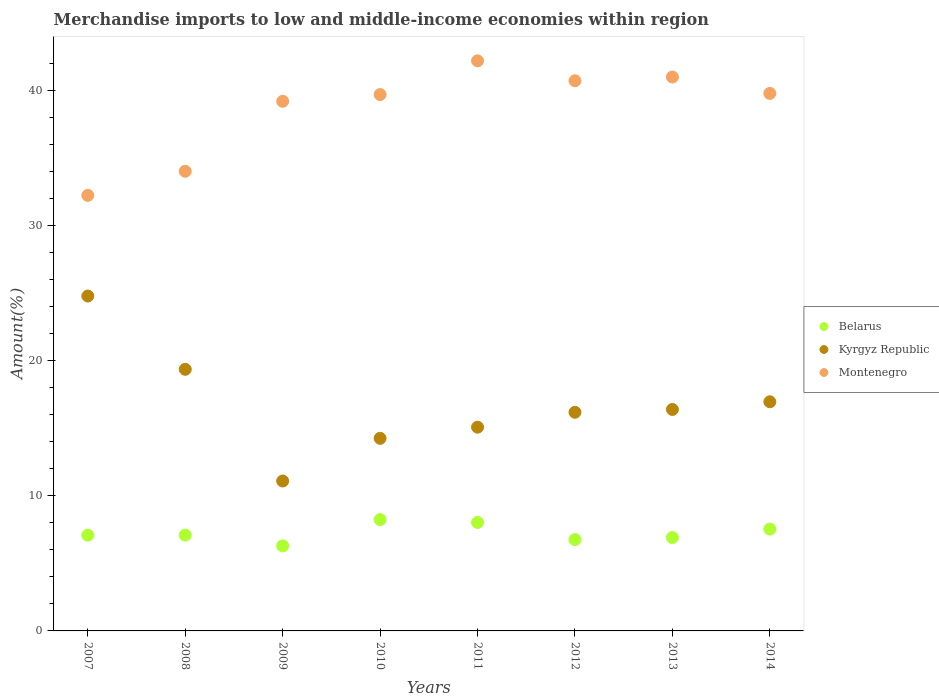How many different coloured dotlines are there?
Make the answer very short. 3. Is the number of dotlines equal to the number of legend labels?
Ensure brevity in your answer.  Yes. What is the percentage of amount earned from merchandise imports in Kyrgyz Republic in 2011?
Keep it short and to the point. 15.07. Across all years, what is the maximum percentage of amount earned from merchandise imports in Kyrgyz Republic?
Your answer should be compact. 24.77. Across all years, what is the minimum percentage of amount earned from merchandise imports in Belarus?
Keep it short and to the point. 6.29. In which year was the percentage of amount earned from merchandise imports in Kyrgyz Republic maximum?
Offer a terse response. 2007. In which year was the percentage of amount earned from merchandise imports in Kyrgyz Republic minimum?
Your answer should be compact. 2009. What is the total percentage of amount earned from merchandise imports in Belarus in the graph?
Keep it short and to the point. 57.93. What is the difference between the percentage of amount earned from merchandise imports in Belarus in 2012 and that in 2014?
Your answer should be compact. -0.77. What is the difference between the percentage of amount earned from merchandise imports in Montenegro in 2011 and the percentage of amount earned from merchandise imports in Belarus in 2007?
Make the answer very short. 35.09. What is the average percentage of amount earned from merchandise imports in Kyrgyz Republic per year?
Your answer should be very brief. 16.76. In the year 2008, what is the difference between the percentage of amount earned from merchandise imports in Kyrgyz Republic and percentage of amount earned from merchandise imports in Belarus?
Provide a short and direct response. 12.27. What is the ratio of the percentage of amount earned from merchandise imports in Belarus in 2010 to that in 2012?
Your answer should be compact. 1.22. Is the percentage of amount earned from merchandise imports in Belarus in 2009 less than that in 2012?
Provide a short and direct response. Yes. What is the difference between the highest and the second highest percentage of amount earned from merchandise imports in Kyrgyz Republic?
Keep it short and to the point. 5.42. What is the difference between the highest and the lowest percentage of amount earned from merchandise imports in Montenegro?
Provide a short and direct response. 9.95. Is it the case that in every year, the sum of the percentage of amount earned from merchandise imports in Kyrgyz Republic and percentage of amount earned from merchandise imports in Montenegro  is greater than the percentage of amount earned from merchandise imports in Belarus?
Offer a terse response. Yes. Does the graph contain grids?
Your answer should be very brief. No. How are the legend labels stacked?
Your response must be concise. Vertical. What is the title of the graph?
Your answer should be very brief. Merchandise imports to low and middle-income economies within region. What is the label or title of the Y-axis?
Your response must be concise. Amount(%). What is the Amount(%) in Belarus in 2007?
Your answer should be very brief. 7.08. What is the Amount(%) of Kyrgyz Republic in 2007?
Your answer should be very brief. 24.77. What is the Amount(%) of Montenegro in 2007?
Offer a very short reply. 32.22. What is the Amount(%) of Belarus in 2008?
Ensure brevity in your answer.  7.09. What is the Amount(%) of Kyrgyz Republic in 2008?
Offer a terse response. 19.35. What is the Amount(%) in Montenegro in 2008?
Your answer should be compact. 34. What is the Amount(%) in Belarus in 2009?
Your answer should be compact. 6.29. What is the Amount(%) in Kyrgyz Republic in 2009?
Your answer should be compact. 11.09. What is the Amount(%) of Montenegro in 2009?
Offer a terse response. 39.18. What is the Amount(%) in Belarus in 2010?
Your response must be concise. 8.24. What is the Amount(%) in Kyrgyz Republic in 2010?
Give a very brief answer. 14.25. What is the Amount(%) of Montenegro in 2010?
Give a very brief answer. 39.68. What is the Amount(%) in Belarus in 2011?
Keep it short and to the point. 8.03. What is the Amount(%) of Kyrgyz Republic in 2011?
Your answer should be very brief. 15.07. What is the Amount(%) of Montenegro in 2011?
Provide a succinct answer. 42.17. What is the Amount(%) of Belarus in 2012?
Your answer should be compact. 6.76. What is the Amount(%) of Kyrgyz Republic in 2012?
Offer a terse response. 16.17. What is the Amount(%) in Montenegro in 2012?
Your answer should be compact. 40.7. What is the Amount(%) of Belarus in 2013?
Your response must be concise. 6.91. What is the Amount(%) of Kyrgyz Republic in 2013?
Make the answer very short. 16.38. What is the Amount(%) of Montenegro in 2013?
Offer a terse response. 40.98. What is the Amount(%) of Belarus in 2014?
Provide a short and direct response. 7.53. What is the Amount(%) in Kyrgyz Republic in 2014?
Your answer should be very brief. 16.95. What is the Amount(%) in Montenegro in 2014?
Offer a very short reply. 39.76. Across all years, what is the maximum Amount(%) of Belarus?
Provide a short and direct response. 8.24. Across all years, what is the maximum Amount(%) in Kyrgyz Republic?
Offer a very short reply. 24.77. Across all years, what is the maximum Amount(%) of Montenegro?
Offer a terse response. 42.17. Across all years, what is the minimum Amount(%) of Belarus?
Give a very brief answer. 6.29. Across all years, what is the minimum Amount(%) of Kyrgyz Republic?
Offer a very short reply. 11.09. Across all years, what is the minimum Amount(%) of Montenegro?
Provide a short and direct response. 32.22. What is the total Amount(%) of Belarus in the graph?
Keep it short and to the point. 57.93. What is the total Amount(%) of Kyrgyz Republic in the graph?
Provide a succinct answer. 134.05. What is the total Amount(%) of Montenegro in the graph?
Provide a short and direct response. 308.69. What is the difference between the Amount(%) in Belarus in 2007 and that in 2008?
Offer a very short reply. -0. What is the difference between the Amount(%) in Kyrgyz Republic in 2007 and that in 2008?
Your answer should be compact. 5.42. What is the difference between the Amount(%) in Montenegro in 2007 and that in 2008?
Keep it short and to the point. -1.78. What is the difference between the Amount(%) of Belarus in 2007 and that in 2009?
Offer a terse response. 0.79. What is the difference between the Amount(%) in Kyrgyz Republic in 2007 and that in 2009?
Your answer should be very brief. 13.68. What is the difference between the Amount(%) of Montenegro in 2007 and that in 2009?
Offer a terse response. -6.96. What is the difference between the Amount(%) of Belarus in 2007 and that in 2010?
Ensure brevity in your answer.  -1.15. What is the difference between the Amount(%) of Kyrgyz Republic in 2007 and that in 2010?
Offer a terse response. 10.53. What is the difference between the Amount(%) in Montenegro in 2007 and that in 2010?
Your response must be concise. -7.46. What is the difference between the Amount(%) of Belarus in 2007 and that in 2011?
Your answer should be compact. -0.94. What is the difference between the Amount(%) in Kyrgyz Republic in 2007 and that in 2011?
Your answer should be compact. 9.7. What is the difference between the Amount(%) in Montenegro in 2007 and that in 2011?
Your answer should be compact. -9.95. What is the difference between the Amount(%) of Belarus in 2007 and that in 2012?
Ensure brevity in your answer.  0.32. What is the difference between the Amount(%) of Kyrgyz Republic in 2007 and that in 2012?
Your answer should be very brief. 8.6. What is the difference between the Amount(%) of Montenegro in 2007 and that in 2012?
Provide a short and direct response. -8.48. What is the difference between the Amount(%) in Belarus in 2007 and that in 2013?
Give a very brief answer. 0.17. What is the difference between the Amount(%) in Kyrgyz Republic in 2007 and that in 2013?
Your response must be concise. 8.39. What is the difference between the Amount(%) in Montenegro in 2007 and that in 2013?
Your answer should be compact. -8.76. What is the difference between the Amount(%) in Belarus in 2007 and that in 2014?
Provide a short and direct response. -0.45. What is the difference between the Amount(%) in Kyrgyz Republic in 2007 and that in 2014?
Your answer should be very brief. 7.82. What is the difference between the Amount(%) of Montenegro in 2007 and that in 2014?
Ensure brevity in your answer.  -7.54. What is the difference between the Amount(%) of Belarus in 2008 and that in 2009?
Give a very brief answer. 0.8. What is the difference between the Amount(%) of Kyrgyz Republic in 2008 and that in 2009?
Provide a succinct answer. 8.26. What is the difference between the Amount(%) in Montenegro in 2008 and that in 2009?
Provide a short and direct response. -5.18. What is the difference between the Amount(%) in Belarus in 2008 and that in 2010?
Give a very brief answer. -1.15. What is the difference between the Amount(%) in Kyrgyz Republic in 2008 and that in 2010?
Offer a terse response. 5.11. What is the difference between the Amount(%) of Montenegro in 2008 and that in 2010?
Provide a succinct answer. -5.68. What is the difference between the Amount(%) in Belarus in 2008 and that in 2011?
Ensure brevity in your answer.  -0.94. What is the difference between the Amount(%) of Kyrgyz Republic in 2008 and that in 2011?
Ensure brevity in your answer.  4.28. What is the difference between the Amount(%) of Montenegro in 2008 and that in 2011?
Ensure brevity in your answer.  -8.17. What is the difference between the Amount(%) in Belarus in 2008 and that in 2012?
Give a very brief answer. 0.33. What is the difference between the Amount(%) in Kyrgyz Republic in 2008 and that in 2012?
Provide a succinct answer. 3.18. What is the difference between the Amount(%) of Montenegro in 2008 and that in 2012?
Provide a succinct answer. -6.7. What is the difference between the Amount(%) in Belarus in 2008 and that in 2013?
Offer a very short reply. 0.18. What is the difference between the Amount(%) of Kyrgyz Republic in 2008 and that in 2013?
Make the answer very short. 2.97. What is the difference between the Amount(%) in Montenegro in 2008 and that in 2013?
Give a very brief answer. -6.97. What is the difference between the Amount(%) of Belarus in 2008 and that in 2014?
Offer a very short reply. -0.45. What is the difference between the Amount(%) in Kyrgyz Republic in 2008 and that in 2014?
Make the answer very short. 2.4. What is the difference between the Amount(%) in Montenegro in 2008 and that in 2014?
Offer a very short reply. -5.76. What is the difference between the Amount(%) in Belarus in 2009 and that in 2010?
Provide a short and direct response. -1.95. What is the difference between the Amount(%) in Kyrgyz Republic in 2009 and that in 2010?
Ensure brevity in your answer.  -3.16. What is the difference between the Amount(%) in Montenegro in 2009 and that in 2010?
Make the answer very short. -0.5. What is the difference between the Amount(%) in Belarus in 2009 and that in 2011?
Give a very brief answer. -1.74. What is the difference between the Amount(%) in Kyrgyz Republic in 2009 and that in 2011?
Your answer should be compact. -3.98. What is the difference between the Amount(%) of Montenegro in 2009 and that in 2011?
Your response must be concise. -2.99. What is the difference between the Amount(%) in Belarus in 2009 and that in 2012?
Your answer should be compact. -0.47. What is the difference between the Amount(%) in Kyrgyz Republic in 2009 and that in 2012?
Your answer should be compact. -5.08. What is the difference between the Amount(%) of Montenegro in 2009 and that in 2012?
Offer a very short reply. -1.52. What is the difference between the Amount(%) of Belarus in 2009 and that in 2013?
Your answer should be very brief. -0.62. What is the difference between the Amount(%) of Kyrgyz Republic in 2009 and that in 2013?
Give a very brief answer. -5.29. What is the difference between the Amount(%) of Montenegro in 2009 and that in 2013?
Keep it short and to the point. -1.8. What is the difference between the Amount(%) of Belarus in 2009 and that in 2014?
Offer a very short reply. -1.24. What is the difference between the Amount(%) of Kyrgyz Republic in 2009 and that in 2014?
Make the answer very short. -5.86. What is the difference between the Amount(%) in Montenegro in 2009 and that in 2014?
Your answer should be very brief. -0.58. What is the difference between the Amount(%) of Belarus in 2010 and that in 2011?
Ensure brevity in your answer.  0.21. What is the difference between the Amount(%) in Kyrgyz Republic in 2010 and that in 2011?
Provide a short and direct response. -0.82. What is the difference between the Amount(%) in Montenegro in 2010 and that in 2011?
Make the answer very short. -2.49. What is the difference between the Amount(%) in Belarus in 2010 and that in 2012?
Your answer should be compact. 1.48. What is the difference between the Amount(%) of Kyrgyz Republic in 2010 and that in 2012?
Give a very brief answer. -1.93. What is the difference between the Amount(%) of Montenegro in 2010 and that in 2012?
Ensure brevity in your answer.  -1.02. What is the difference between the Amount(%) of Belarus in 2010 and that in 2013?
Offer a terse response. 1.33. What is the difference between the Amount(%) of Kyrgyz Republic in 2010 and that in 2013?
Make the answer very short. -2.13. What is the difference between the Amount(%) of Montenegro in 2010 and that in 2013?
Make the answer very short. -1.3. What is the difference between the Amount(%) of Belarus in 2010 and that in 2014?
Offer a very short reply. 0.7. What is the difference between the Amount(%) in Kyrgyz Republic in 2010 and that in 2014?
Make the answer very short. -2.7. What is the difference between the Amount(%) in Montenegro in 2010 and that in 2014?
Provide a short and direct response. -0.08. What is the difference between the Amount(%) in Belarus in 2011 and that in 2012?
Make the answer very short. 1.27. What is the difference between the Amount(%) in Kyrgyz Republic in 2011 and that in 2012?
Offer a very short reply. -1.1. What is the difference between the Amount(%) in Montenegro in 2011 and that in 2012?
Keep it short and to the point. 1.47. What is the difference between the Amount(%) in Belarus in 2011 and that in 2013?
Keep it short and to the point. 1.12. What is the difference between the Amount(%) of Kyrgyz Republic in 2011 and that in 2013?
Give a very brief answer. -1.31. What is the difference between the Amount(%) in Montenegro in 2011 and that in 2013?
Offer a terse response. 1.2. What is the difference between the Amount(%) of Belarus in 2011 and that in 2014?
Keep it short and to the point. 0.49. What is the difference between the Amount(%) in Kyrgyz Republic in 2011 and that in 2014?
Provide a short and direct response. -1.88. What is the difference between the Amount(%) of Montenegro in 2011 and that in 2014?
Your response must be concise. 2.41. What is the difference between the Amount(%) of Belarus in 2012 and that in 2013?
Your answer should be very brief. -0.15. What is the difference between the Amount(%) of Kyrgyz Republic in 2012 and that in 2013?
Offer a very short reply. -0.21. What is the difference between the Amount(%) in Montenegro in 2012 and that in 2013?
Keep it short and to the point. -0.28. What is the difference between the Amount(%) of Belarus in 2012 and that in 2014?
Offer a very short reply. -0.77. What is the difference between the Amount(%) of Kyrgyz Republic in 2012 and that in 2014?
Offer a terse response. -0.78. What is the difference between the Amount(%) of Montenegro in 2012 and that in 2014?
Provide a short and direct response. 0.94. What is the difference between the Amount(%) of Belarus in 2013 and that in 2014?
Your response must be concise. -0.62. What is the difference between the Amount(%) in Kyrgyz Republic in 2013 and that in 2014?
Your answer should be very brief. -0.57. What is the difference between the Amount(%) of Montenegro in 2013 and that in 2014?
Provide a short and direct response. 1.21. What is the difference between the Amount(%) in Belarus in 2007 and the Amount(%) in Kyrgyz Republic in 2008?
Ensure brevity in your answer.  -12.27. What is the difference between the Amount(%) of Belarus in 2007 and the Amount(%) of Montenegro in 2008?
Ensure brevity in your answer.  -26.92. What is the difference between the Amount(%) of Kyrgyz Republic in 2007 and the Amount(%) of Montenegro in 2008?
Your answer should be very brief. -9.23. What is the difference between the Amount(%) in Belarus in 2007 and the Amount(%) in Kyrgyz Republic in 2009?
Keep it short and to the point. -4.01. What is the difference between the Amount(%) in Belarus in 2007 and the Amount(%) in Montenegro in 2009?
Your answer should be very brief. -32.09. What is the difference between the Amount(%) of Kyrgyz Republic in 2007 and the Amount(%) of Montenegro in 2009?
Ensure brevity in your answer.  -14.41. What is the difference between the Amount(%) of Belarus in 2007 and the Amount(%) of Kyrgyz Republic in 2010?
Offer a very short reply. -7.16. What is the difference between the Amount(%) in Belarus in 2007 and the Amount(%) in Montenegro in 2010?
Offer a very short reply. -32.59. What is the difference between the Amount(%) in Kyrgyz Republic in 2007 and the Amount(%) in Montenegro in 2010?
Give a very brief answer. -14.9. What is the difference between the Amount(%) of Belarus in 2007 and the Amount(%) of Kyrgyz Republic in 2011?
Ensure brevity in your answer.  -7.99. What is the difference between the Amount(%) of Belarus in 2007 and the Amount(%) of Montenegro in 2011?
Keep it short and to the point. -35.09. What is the difference between the Amount(%) of Kyrgyz Republic in 2007 and the Amount(%) of Montenegro in 2011?
Your answer should be compact. -17.4. What is the difference between the Amount(%) of Belarus in 2007 and the Amount(%) of Kyrgyz Republic in 2012?
Offer a terse response. -9.09. What is the difference between the Amount(%) of Belarus in 2007 and the Amount(%) of Montenegro in 2012?
Offer a terse response. -33.61. What is the difference between the Amount(%) of Kyrgyz Republic in 2007 and the Amount(%) of Montenegro in 2012?
Keep it short and to the point. -15.93. What is the difference between the Amount(%) in Belarus in 2007 and the Amount(%) in Kyrgyz Republic in 2013?
Offer a very short reply. -9.3. What is the difference between the Amount(%) of Belarus in 2007 and the Amount(%) of Montenegro in 2013?
Provide a short and direct response. -33.89. What is the difference between the Amount(%) of Kyrgyz Republic in 2007 and the Amount(%) of Montenegro in 2013?
Make the answer very short. -16.2. What is the difference between the Amount(%) of Belarus in 2007 and the Amount(%) of Kyrgyz Republic in 2014?
Keep it short and to the point. -9.87. What is the difference between the Amount(%) in Belarus in 2007 and the Amount(%) in Montenegro in 2014?
Offer a very short reply. -32.68. What is the difference between the Amount(%) of Kyrgyz Republic in 2007 and the Amount(%) of Montenegro in 2014?
Give a very brief answer. -14.99. What is the difference between the Amount(%) in Belarus in 2008 and the Amount(%) in Kyrgyz Republic in 2009?
Offer a terse response. -4. What is the difference between the Amount(%) of Belarus in 2008 and the Amount(%) of Montenegro in 2009?
Offer a terse response. -32.09. What is the difference between the Amount(%) of Kyrgyz Republic in 2008 and the Amount(%) of Montenegro in 2009?
Offer a very short reply. -19.83. What is the difference between the Amount(%) in Belarus in 2008 and the Amount(%) in Kyrgyz Republic in 2010?
Your response must be concise. -7.16. What is the difference between the Amount(%) of Belarus in 2008 and the Amount(%) of Montenegro in 2010?
Offer a terse response. -32.59. What is the difference between the Amount(%) in Kyrgyz Republic in 2008 and the Amount(%) in Montenegro in 2010?
Provide a succinct answer. -20.32. What is the difference between the Amount(%) of Belarus in 2008 and the Amount(%) of Kyrgyz Republic in 2011?
Your response must be concise. -7.99. What is the difference between the Amount(%) of Belarus in 2008 and the Amount(%) of Montenegro in 2011?
Your answer should be compact. -35.09. What is the difference between the Amount(%) of Kyrgyz Republic in 2008 and the Amount(%) of Montenegro in 2011?
Make the answer very short. -22.82. What is the difference between the Amount(%) in Belarus in 2008 and the Amount(%) in Kyrgyz Republic in 2012?
Ensure brevity in your answer.  -9.09. What is the difference between the Amount(%) of Belarus in 2008 and the Amount(%) of Montenegro in 2012?
Your response must be concise. -33.61. What is the difference between the Amount(%) of Kyrgyz Republic in 2008 and the Amount(%) of Montenegro in 2012?
Your answer should be very brief. -21.35. What is the difference between the Amount(%) of Belarus in 2008 and the Amount(%) of Kyrgyz Republic in 2013?
Your response must be concise. -9.3. What is the difference between the Amount(%) of Belarus in 2008 and the Amount(%) of Montenegro in 2013?
Give a very brief answer. -33.89. What is the difference between the Amount(%) in Kyrgyz Republic in 2008 and the Amount(%) in Montenegro in 2013?
Provide a short and direct response. -21.62. What is the difference between the Amount(%) in Belarus in 2008 and the Amount(%) in Kyrgyz Republic in 2014?
Provide a short and direct response. -9.87. What is the difference between the Amount(%) in Belarus in 2008 and the Amount(%) in Montenegro in 2014?
Your answer should be very brief. -32.68. What is the difference between the Amount(%) of Kyrgyz Republic in 2008 and the Amount(%) of Montenegro in 2014?
Provide a succinct answer. -20.41. What is the difference between the Amount(%) of Belarus in 2009 and the Amount(%) of Kyrgyz Republic in 2010?
Offer a very short reply. -7.96. What is the difference between the Amount(%) of Belarus in 2009 and the Amount(%) of Montenegro in 2010?
Your answer should be compact. -33.39. What is the difference between the Amount(%) of Kyrgyz Republic in 2009 and the Amount(%) of Montenegro in 2010?
Give a very brief answer. -28.59. What is the difference between the Amount(%) in Belarus in 2009 and the Amount(%) in Kyrgyz Republic in 2011?
Your answer should be compact. -8.78. What is the difference between the Amount(%) in Belarus in 2009 and the Amount(%) in Montenegro in 2011?
Your response must be concise. -35.88. What is the difference between the Amount(%) of Kyrgyz Republic in 2009 and the Amount(%) of Montenegro in 2011?
Your response must be concise. -31.08. What is the difference between the Amount(%) of Belarus in 2009 and the Amount(%) of Kyrgyz Republic in 2012?
Keep it short and to the point. -9.88. What is the difference between the Amount(%) of Belarus in 2009 and the Amount(%) of Montenegro in 2012?
Offer a terse response. -34.41. What is the difference between the Amount(%) of Kyrgyz Republic in 2009 and the Amount(%) of Montenegro in 2012?
Provide a short and direct response. -29.61. What is the difference between the Amount(%) of Belarus in 2009 and the Amount(%) of Kyrgyz Republic in 2013?
Provide a short and direct response. -10.09. What is the difference between the Amount(%) of Belarus in 2009 and the Amount(%) of Montenegro in 2013?
Give a very brief answer. -34.69. What is the difference between the Amount(%) in Kyrgyz Republic in 2009 and the Amount(%) in Montenegro in 2013?
Your answer should be compact. -29.89. What is the difference between the Amount(%) of Belarus in 2009 and the Amount(%) of Kyrgyz Republic in 2014?
Your answer should be very brief. -10.66. What is the difference between the Amount(%) of Belarus in 2009 and the Amount(%) of Montenegro in 2014?
Your answer should be very brief. -33.47. What is the difference between the Amount(%) in Kyrgyz Republic in 2009 and the Amount(%) in Montenegro in 2014?
Give a very brief answer. -28.67. What is the difference between the Amount(%) in Belarus in 2010 and the Amount(%) in Kyrgyz Republic in 2011?
Offer a terse response. -6.83. What is the difference between the Amount(%) in Belarus in 2010 and the Amount(%) in Montenegro in 2011?
Give a very brief answer. -33.94. What is the difference between the Amount(%) in Kyrgyz Republic in 2010 and the Amount(%) in Montenegro in 2011?
Give a very brief answer. -27.93. What is the difference between the Amount(%) in Belarus in 2010 and the Amount(%) in Kyrgyz Republic in 2012?
Make the answer very short. -7.94. What is the difference between the Amount(%) of Belarus in 2010 and the Amount(%) of Montenegro in 2012?
Your response must be concise. -32.46. What is the difference between the Amount(%) of Kyrgyz Republic in 2010 and the Amount(%) of Montenegro in 2012?
Your response must be concise. -26.45. What is the difference between the Amount(%) in Belarus in 2010 and the Amount(%) in Kyrgyz Republic in 2013?
Make the answer very short. -8.15. What is the difference between the Amount(%) in Belarus in 2010 and the Amount(%) in Montenegro in 2013?
Give a very brief answer. -32.74. What is the difference between the Amount(%) of Kyrgyz Republic in 2010 and the Amount(%) of Montenegro in 2013?
Provide a short and direct response. -26.73. What is the difference between the Amount(%) in Belarus in 2010 and the Amount(%) in Kyrgyz Republic in 2014?
Your answer should be compact. -8.71. What is the difference between the Amount(%) of Belarus in 2010 and the Amount(%) of Montenegro in 2014?
Your response must be concise. -31.52. What is the difference between the Amount(%) in Kyrgyz Republic in 2010 and the Amount(%) in Montenegro in 2014?
Provide a succinct answer. -25.51. What is the difference between the Amount(%) of Belarus in 2011 and the Amount(%) of Kyrgyz Republic in 2012?
Your answer should be very brief. -8.15. What is the difference between the Amount(%) of Belarus in 2011 and the Amount(%) of Montenegro in 2012?
Give a very brief answer. -32.67. What is the difference between the Amount(%) of Kyrgyz Republic in 2011 and the Amount(%) of Montenegro in 2012?
Your answer should be very brief. -25.63. What is the difference between the Amount(%) of Belarus in 2011 and the Amount(%) of Kyrgyz Republic in 2013?
Your response must be concise. -8.35. What is the difference between the Amount(%) in Belarus in 2011 and the Amount(%) in Montenegro in 2013?
Give a very brief answer. -32.95. What is the difference between the Amount(%) in Kyrgyz Republic in 2011 and the Amount(%) in Montenegro in 2013?
Provide a short and direct response. -25.9. What is the difference between the Amount(%) of Belarus in 2011 and the Amount(%) of Kyrgyz Republic in 2014?
Provide a succinct answer. -8.92. What is the difference between the Amount(%) in Belarus in 2011 and the Amount(%) in Montenegro in 2014?
Keep it short and to the point. -31.73. What is the difference between the Amount(%) in Kyrgyz Republic in 2011 and the Amount(%) in Montenegro in 2014?
Make the answer very short. -24.69. What is the difference between the Amount(%) of Belarus in 2012 and the Amount(%) of Kyrgyz Republic in 2013?
Provide a short and direct response. -9.62. What is the difference between the Amount(%) in Belarus in 2012 and the Amount(%) in Montenegro in 2013?
Ensure brevity in your answer.  -34.22. What is the difference between the Amount(%) of Kyrgyz Republic in 2012 and the Amount(%) of Montenegro in 2013?
Provide a short and direct response. -24.8. What is the difference between the Amount(%) in Belarus in 2012 and the Amount(%) in Kyrgyz Republic in 2014?
Keep it short and to the point. -10.19. What is the difference between the Amount(%) of Belarus in 2012 and the Amount(%) of Montenegro in 2014?
Your answer should be very brief. -33. What is the difference between the Amount(%) in Kyrgyz Republic in 2012 and the Amount(%) in Montenegro in 2014?
Provide a succinct answer. -23.59. What is the difference between the Amount(%) in Belarus in 2013 and the Amount(%) in Kyrgyz Republic in 2014?
Your answer should be compact. -10.04. What is the difference between the Amount(%) in Belarus in 2013 and the Amount(%) in Montenegro in 2014?
Keep it short and to the point. -32.85. What is the difference between the Amount(%) in Kyrgyz Republic in 2013 and the Amount(%) in Montenegro in 2014?
Provide a succinct answer. -23.38. What is the average Amount(%) in Belarus per year?
Ensure brevity in your answer.  7.24. What is the average Amount(%) in Kyrgyz Republic per year?
Make the answer very short. 16.76. What is the average Amount(%) of Montenegro per year?
Offer a terse response. 38.59. In the year 2007, what is the difference between the Amount(%) of Belarus and Amount(%) of Kyrgyz Republic?
Provide a short and direct response. -17.69. In the year 2007, what is the difference between the Amount(%) of Belarus and Amount(%) of Montenegro?
Make the answer very short. -25.14. In the year 2007, what is the difference between the Amount(%) in Kyrgyz Republic and Amount(%) in Montenegro?
Keep it short and to the point. -7.45. In the year 2008, what is the difference between the Amount(%) of Belarus and Amount(%) of Kyrgyz Republic?
Provide a succinct answer. -12.27. In the year 2008, what is the difference between the Amount(%) in Belarus and Amount(%) in Montenegro?
Provide a short and direct response. -26.91. In the year 2008, what is the difference between the Amount(%) in Kyrgyz Republic and Amount(%) in Montenegro?
Provide a short and direct response. -14.65. In the year 2009, what is the difference between the Amount(%) in Belarus and Amount(%) in Kyrgyz Republic?
Give a very brief answer. -4.8. In the year 2009, what is the difference between the Amount(%) in Belarus and Amount(%) in Montenegro?
Provide a succinct answer. -32.89. In the year 2009, what is the difference between the Amount(%) of Kyrgyz Republic and Amount(%) of Montenegro?
Your response must be concise. -28.09. In the year 2010, what is the difference between the Amount(%) in Belarus and Amount(%) in Kyrgyz Republic?
Your answer should be very brief. -6.01. In the year 2010, what is the difference between the Amount(%) in Belarus and Amount(%) in Montenegro?
Your response must be concise. -31.44. In the year 2010, what is the difference between the Amount(%) in Kyrgyz Republic and Amount(%) in Montenegro?
Keep it short and to the point. -25.43. In the year 2011, what is the difference between the Amount(%) of Belarus and Amount(%) of Kyrgyz Republic?
Your response must be concise. -7.04. In the year 2011, what is the difference between the Amount(%) in Belarus and Amount(%) in Montenegro?
Keep it short and to the point. -34.14. In the year 2011, what is the difference between the Amount(%) of Kyrgyz Republic and Amount(%) of Montenegro?
Keep it short and to the point. -27.1. In the year 2012, what is the difference between the Amount(%) in Belarus and Amount(%) in Kyrgyz Republic?
Make the answer very short. -9.42. In the year 2012, what is the difference between the Amount(%) in Belarus and Amount(%) in Montenegro?
Your answer should be compact. -33.94. In the year 2012, what is the difference between the Amount(%) in Kyrgyz Republic and Amount(%) in Montenegro?
Provide a succinct answer. -24.52. In the year 2013, what is the difference between the Amount(%) in Belarus and Amount(%) in Kyrgyz Republic?
Your answer should be compact. -9.47. In the year 2013, what is the difference between the Amount(%) of Belarus and Amount(%) of Montenegro?
Keep it short and to the point. -34.07. In the year 2013, what is the difference between the Amount(%) in Kyrgyz Republic and Amount(%) in Montenegro?
Ensure brevity in your answer.  -24.59. In the year 2014, what is the difference between the Amount(%) in Belarus and Amount(%) in Kyrgyz Republic?
Offer a terse response. -9.42. In the year 2014, what is the difference between the Amount(%) in Belarus and Amount(%) in Montenegro?
Keep it short and to the point. -32.23. In the year 2014, what is the difference between the Amount(%) in Kyrgyz Republic and Amount(%) in Montenegro?
Provide a short and direct response. -22.81. What is the ratio of the Amount(%) of Belarus in 2007 to that in 2008?
Offer a terse response. 1. What is the ratio of the Amount(%) in Kyrgyz Republic in 2007 to that in 2008?
Your answer should be compact. 1.28. What is the ratio of the Amount(%) of Montenegro in 2007 to that in 2008?
Give a very brief answer. 0.95. What is the ratio of the Amount(%) in Belarus in 2007 to that in 2009?
Offer a very short reply. 1.13. What is the ratio of the Amount(%) of Kyrgyz Republic in 2007 to that in 2009?
Provide a succinct answer. 2.23. What is the ratio of the Amount(%) of Montenegro in 2007 to that in 2009?
Make the answer very short. 0.82. What is the ratio of the Amount(%) of Belarus in 2007 to that in 2010?
Offer a terse response. 0.86. What is the ratio of the Amount(%) of Kyrgyz Republic in 2007 to that in 2010?
Make the answer very short. 1.74. What is the ratio of the Amount(%) of Montenegro in 2007 to that in 2010?
Offer a terse response. 0.81. What is the ratio of the Amount(%) in Belarus in 2007 to that in 2011?
Your answer should be very brief. 0.88. What is the ratio of the Amount(%) in Kyrgyz Republic in 2007 to that in 2011?
Make the answer very short. 1.64. What is the ratio of the Amount(%) in Montenegro in 2007 to that in 2011?
Give a very brief answer. 0.76. What is the ratio of the Amount(%) of Belarus in 2007 to that in 2012?
Provide a short and direct response. 1.05. What is the ratio of the Amount(%) of Kyrgyz Republic in 2007 to that in 2012?
Make the answer very short. 1.53. What is the ratio of the Amount(%) of Montenegro in 2007 to that in 2012?
Ensure brevity in your answer.  0.79. What is the ratio of the Amount(%) in Belarus in 2007 to that in 2013?
Give a very brief answer. 1.03. What is the ratio of the Amount(%) of Kyrgyz Republic in 2007 to that in 2013?
Offer a very short reply. 1.51. What is the ratio of the Amount(%) in Montenegro in 2007 to that in 2013?
Offer a very short reply. 0.79. What is the ratio of the Amount(%) of Belarus in 2007 to that in 2014?
Make the answer very short. 0.94. What is the ratio of the Amount(%) in Kyrgyz Republic in 2007 to that in 2014?
Your response must be concise. 1.46. What is the ratio of the Amount(%) of Montenegro in 2007 to that in 2014?
Your answer should be compact. 0.81. What is the ratio of the Amount(%) of Belarus in 2008 to that in 2009?
Give a very brief answer. 1.13. What is the ratio of the Amount(%) of Kyrgyz Republic in 2008 to that in 2009?
Make the answer very short. 1.75. What is the ratio of the Amount(%) of Montenegro in 2008 to that in 2009?
Give a very brief answer. 0.87. What is the ratio of the Amount(%) of Belarus in 2008 to that in 2010?
Offer a terse response. 0.86. What is the ratio of the Amount(%) in Kyrgyz Republic in 2008 to that in 2010?
Offer a terse response. 1.36. What is the ratio of the Amount(%) of Montenegro in 2008 to that in 2010?
Your response must be concise. 0.86. What is the ratio of the Amount(%) of Belarus in 2008 to that in 2011?
Your response must be concise. 0.88. What is the ratio of the Amount(%) of Kyrgyz Republic in 2008 to that in 2011?
Offer a very short reply. 1.28. What is the ratio of the Amount(%) of Montenegro in 2008 to that in 2011?
Offer a very short reply. 0.81. What is the ratio of the Amount(%) in Belarus in 2008 to that in 2012?
Make the answer very short. 1.05. What is the ratio of the Amount(%) of Kyrgyz Republic in 2008 to that in 2012?
Provide a succinct answer. 1.2. What is the ratio of the Amount(%) in Montenegro in 2008 to that in 2012?
Ensure brevity in your answer.  0.84. What is the ratio of the Amount(%) in Belarus in 2008 to that in 2013?
Provide a succinct answer. 1.03. What is the ratio of the Amount(%) in Kyrgyz Republic in 2008 to that in 2013?
Offer a very short reply. 1.18. What is the ratio of the Amount(%) in Montenegro in 2008 to that in 2013?
Offer a terse response. 0.83. What is the ratio of the Amount(%) of Belarus in 2008 to that in 2014?
Keep it short and to the point. 0.94. What is the ratio of the Amount(%) of Kyrgyz Republic in 2008 to that in 2014?
Keep it short and to the point. 1.14. What is the ratio of the Amount(%) of Montenegro in 2008 to that in 2014?
Ensure brevity in your answer.  0.86. What is the ratio of the Amount(%) of Belarus in 2009 to that in 2010?
Give a very brief answer. 0.76. What is the ratio of the Amount(%) of Kyrgyz Republic in 2009 to that in 2010?
Offer a terse response. 0.78. What is the ratio of the Amount(%) of Montenegro in 2009 to that in 2010?
Provide a succinct answer. 0.99. What is the ratio of the Amount(%) in Belarus in 2009 to that in 2011?
Your answer should be very brief. 0.78. What is the ratio of the Amount(%) of Kyrgyz Republic in 2009 to that in 2011?
Offer a very short reply. 0.74. What is the ratio of the Amount(%) of Montenegro in 2009 to that in 2011?
Ensure brevity in your answer.  0.93. What is the ratio of the Amount(%) in Belarus in 2009 to that in 2012?
Offer a terse response. 0.93. What is the ratio of the Amount(%) in Kyrgyz Republic in 2009 to that in 2012?
Keep it short and to the point. 0.69. What is the ratio of the Amount(%) in Montenegro in 2009 to that in 2012?
Keep it short and to the point. 0.96. What is the ratio of the Amount(%) in Belarus in 2009 to that in 2013?
Give a very brief answer. 0.91. What is the ratio of the Amount(%) of Kyrgyz Republic in 2009 to that in 2013?
Your answer should be compact. 0.68. What is the ratio of the Amount(%) of Montenegro in 2009 to that in 2013?
Your response must be concise. 0.96. What is the ratio of the Amount(%) in Belarus in 2009 to that in 2014?
Make the answer very short. 0.84. What is the ratio of the Amount(%) in Kyrgyz Republic in 2009 to that in 2014?
Provide a short and direct response. 0.65. What is the ratio of the Amount(%) in Belarus in 2010 to that in 2011?
Ensure brevity in your answer.  1.03. What is the ratio of the Amount(%) in Kyrgyz Republic in 2010 to that in 2011?
Offer a very short reply. 0.95. What is the ratio of the Amount(%) in Montenegro in 2010 to that in 2011?
Your answer should be very brief. 0.94. What is the ratio of the Amount(%) of Belarus in 2010 to that in 2012?
Offer a very short reply. 1.22. What is the ratio of the Amount(%) of Kyrgyz Republic in 2010 to that in 2012?
Your answer should be compact. 0.88. What is the ratio of the Amount(%) in Montenegro in 2010 to that in 2012?
Make the answer very short. 0.97. What is the ratio of the Amount(%) in Belarus in 2010 to that in 2013?
Offer a very short reply. 1.19. What is the ratio of the Amount(%) of Kyrgyz Republic in 2010 to that in 2013?
Your answer should be compact. 0.87. What is the ratio of the Amount(%) of Montenegro in 2010 to that in 2013?
Offer a very short reply. 0.97. What is the ratio of the Amount(%) of Belarus in 2010 to that in 2014?
Offer a terse response. 1.09. What is the ratio of the Amount(%) of Kyrgyz Republic in 2010 to that in 2014?
Keep it short and to the point. 0.84. What is the ratio of the Amount(%) of Belarus in 2011 to that in 2012?
Provide a succinct answer. 1.19. What is the ratio of the Amount(%) in Kyrgyz Republic in 2011 to that in 2012?
Your answer should be compact. 0.93. What is the ratio of the Amount(%) of Montenegro in 2011 to that in 2012?
Your answer should be very brief. 1.04. What is the ratio of the Amount(%) in Belarus in 2011 to that in 2013?
Provide a succinct answer. 1.16. What is the ratio of the Amount(%) of Kyrgyz Republic in 2011 to that in 2013?
Keep it short and to the point. 0.92. What is the ratio of the Amount(%) of Montenegro in 2011 to that in 2013?
Your response must be concise. 1.03. What is the ratio of the Amount(%) of Belarus in 2011 to that in 2014?
Your answer should be compact. 1.07. What is the ratio of the Amount(%) of Kyrgyz Republic in 2011 to that in 2014?
Your answer should be compact. 0.89. What is the ratio of the Amount(%) of Montenegro in 2011 to that in 2014?
Ensure brevity in your answer.  1.06. What is the ratio of the Amount(%) in Belarus in 2012 to that in 2013?
Ensure brevity in your answer.  0.98. What is the ratio of the Amount(%) in Kyrgyz Republic in 2012 to that in 2013?
Provide a short and direct response. 0.99. What is the ratio of the Amount(%) of Belarus in 2012 to that in 2014?
Provide a succinct answer. 0.9. What is the ratio of the Amount(%) of Kyrgyz Republic in 2012 to that in 2014?
Make the answer very short. 0.95. What is the ratio of the Amount(%) in Montenegro in 2012 to that in 2014?
Make the answer very short. 1.02. What is the ratio of the Amount(%) of Belarus in 2013 to that in 2014?
Keep it short and to the point. 0.92. What is the ratio of the Amount(%) in Kyrgyz Republic in 2013 to that in 2014?
Offer a terse response. 0.97. What is the ratio of the Amount(%) of Montenegro in 2013 to that in 2014?
Your response must be concise. 1.03. What is the difference between the highest and the second highest Amount(%) of Belarus?
Your response must be concise. 0.21. What is the difference between the highest and the second highest Amount(%) in Kyrgyz Republic?
Make the answer very short. 5.42. What is the difference between the highest and the second highest Amount(%) in Montenegro?
Provide a short and direct response. 1.2. What is the difference between the highest and the lowest Amount(%) in Belarus?
Offer a terse response. 1.95. What is the difference between the highest and the lowest Amount(%) in Kyrgyz Republic?
Give a very brief answer. 13.68. What is the difference between the highest and the lowest Amount(%) of Montenegro?
Your response must be concise. 9.95. 